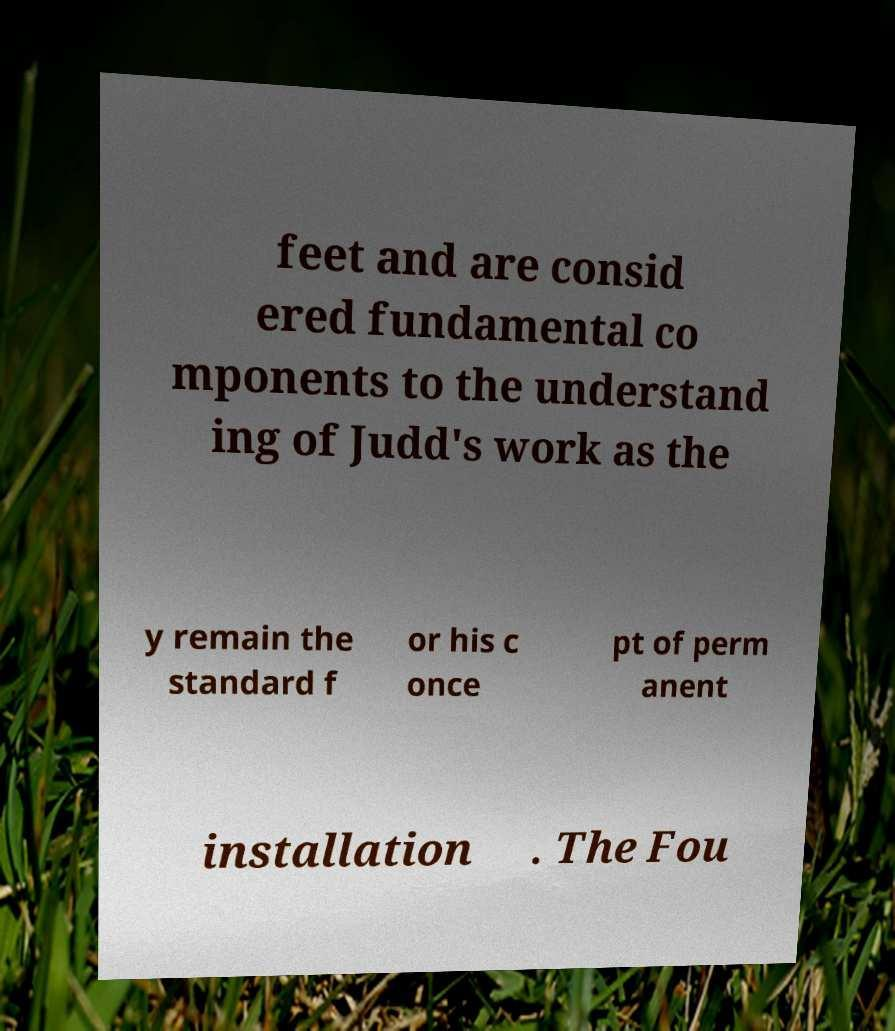For documentation purposes, I need the text within this image transcribed. Could you provide that? feet and are consid ered fundamental co mponents to the understand ing of Judd's work as the y remain the standard f or his c once pt of perm anent installation . The Fou 